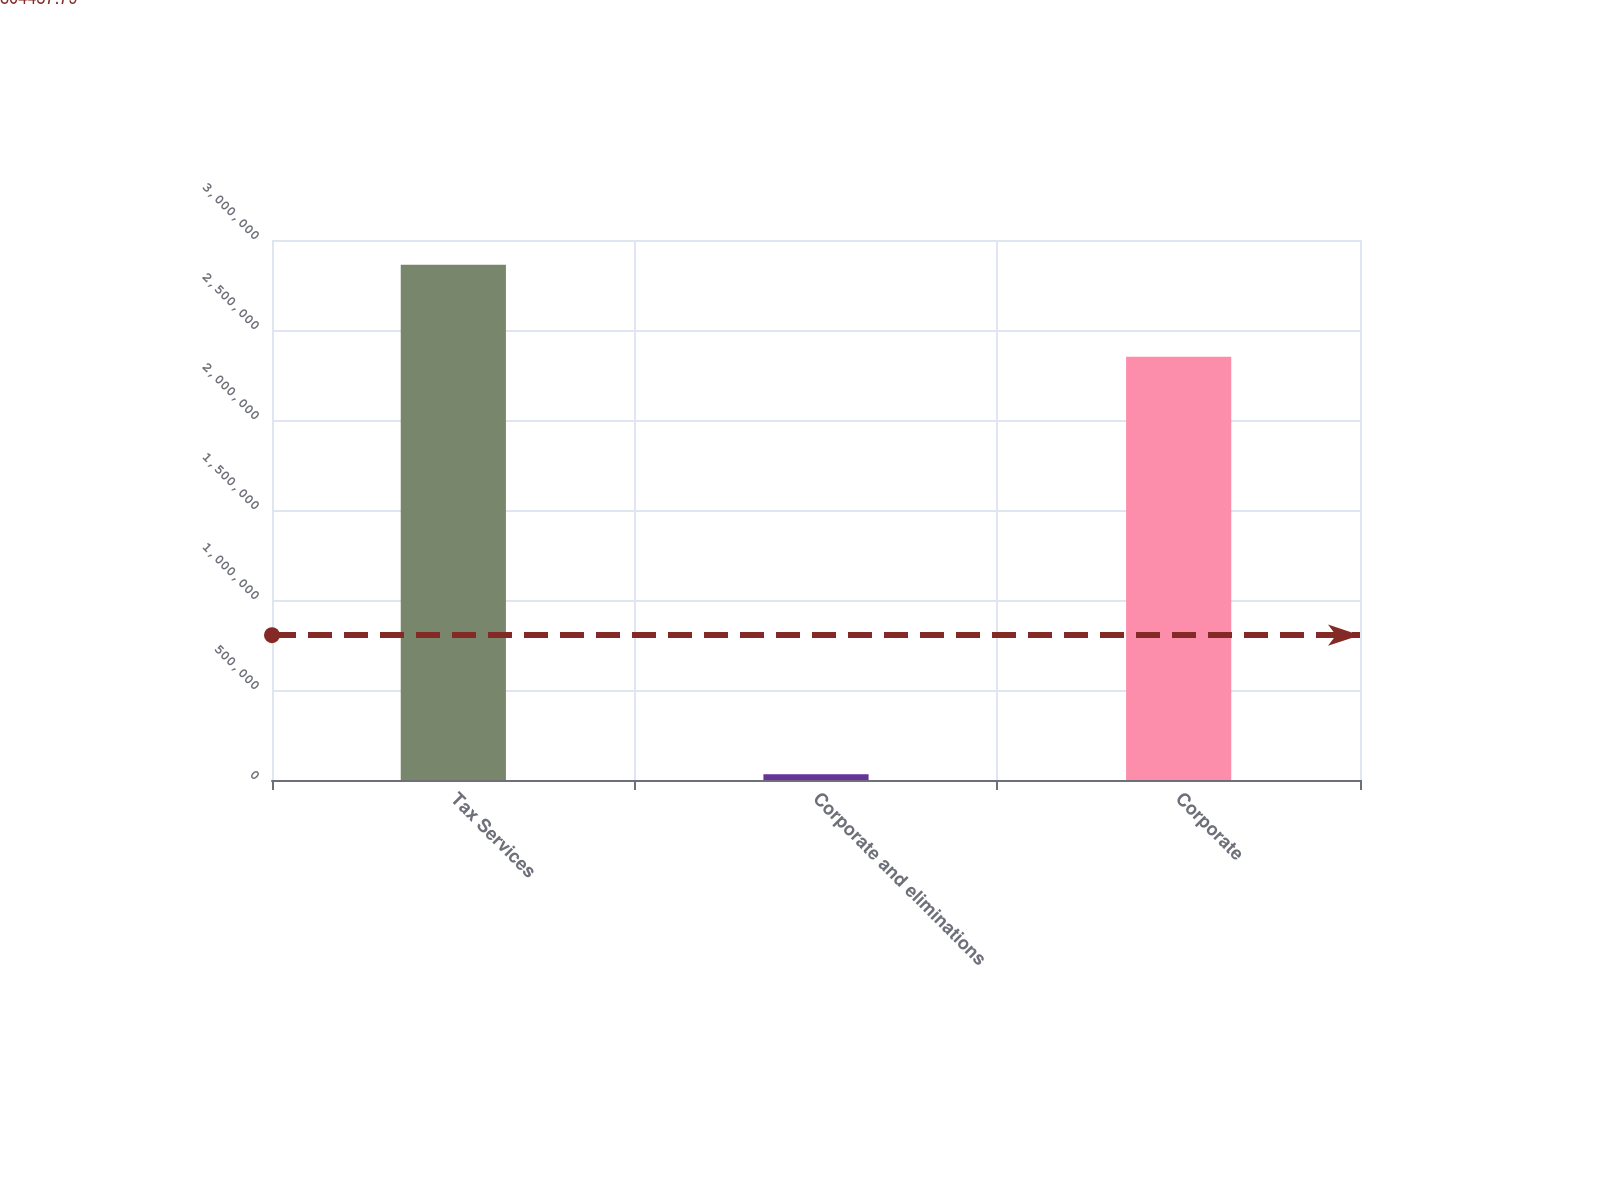Convert chart to OTSL. <chart><loc_0><loc_0><loc_500><loc_500><bar_chart><fcel>Tax Services<fcel>Corporate and eliminations<fcel>Corporate<nl><fcel>2.86238e+06<fcel>31393<fcel>2.35108e+06<nl></chart> 